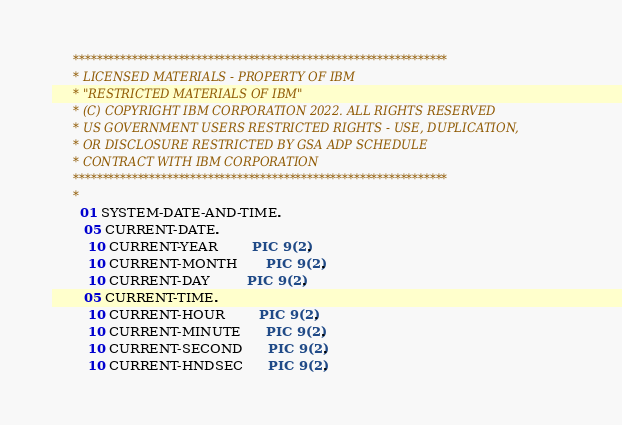<code> <loc_0><loc_0><loc_500><loc_500><_COBOL_>      ****************************************************************
      * LICENSED MATERIALS - PROPERTY OF IBM
      * "RESTRICTED MATERIALS OF IBM"
      * (C) COPYRIGHT IBM CORPORATION 2022. ALL RIGHTS RESERVED
      * US GOVERNMENT USERS RESTRICTED RIGHTS - USE, DUPLICATION,
      * OR DISCLOSURE RESTRICTED BY GSA ADP SCHEDULE
      * CONTRACT WITH IBM CORPORATION
      ****************************************************************
      *
       01 SYSTEM-DATE-AND-TIME.
        05 CURRENT-DATE.
         10 CURRENT-YEAR        PIC 9(2).
         10 CURRENT-MONTH       PIC 9(2).
         10 CURRENT-DAY         PIC 9(2).
        05 CURRENT-TIME.
         10 CURRENT-HOUR        PIC 9(2).
         10 CURRENT-MINUTE      PIC 9(2).
         10 CURRENT-SECOND      PIC 9(2).
         10 CURRENT-HNDSEC      PIC 9(2).</code> 